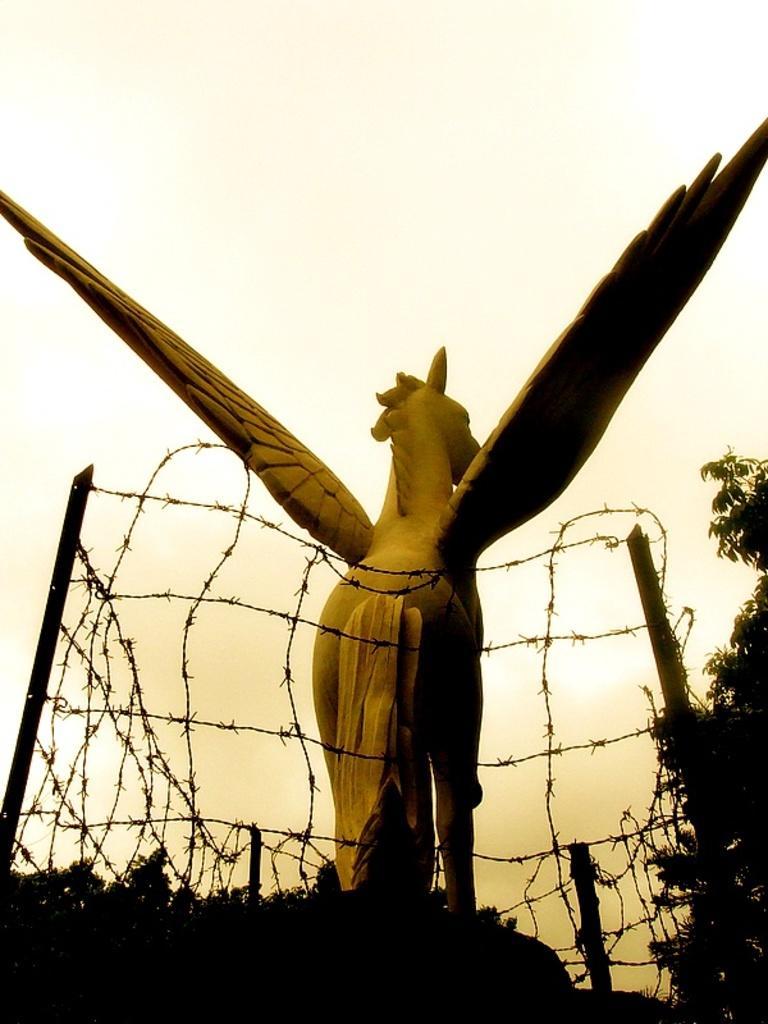How would you summarize this image in a sentence or two? In this image we can see one statue, fence with poles around the statue, some trees and there is the sky in the background. 